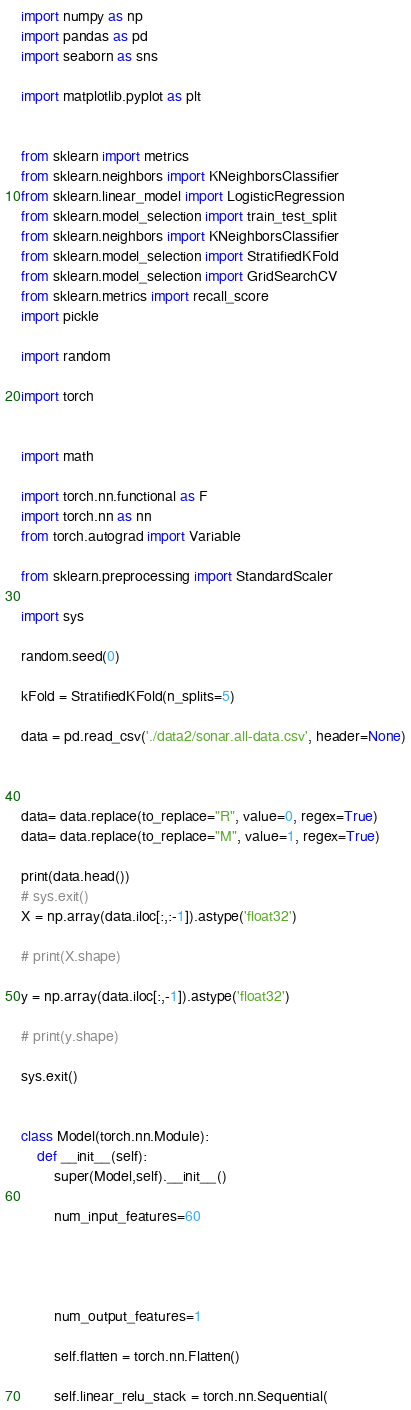Convert code to text. <code><loc_0><loc_0><loc_500><loc_500><_Python_>import numpy as np
import pandas as pd
import seaborn as sns

import matplotlib.pyplot as plt


from sklearn import metrics
from sklearn.neighbors import KNeighborsClassifier
from sklearn.linear_model import LogisticRegression
from sklearn.model_selection import train_test_split
from sklearn.neighbors import KNeighborsClassifier
from sklearn.model_selection import StratifiedKFold
from sklearn.model_selection import GridSearchCV
from sklearn.metrics import recall_score
import pickle

import random

import torch


import math

import torch.nn.functional as F
import torch.nn as nn
from torch.autograd import Variable

from sklearn.preprocessing import StandardScaler

import sys

random.seed(0)

kFold = StratifiedKFold(n_splits=5)

data = pd.read_csv('./data2/sonar.all-data.csv', header=None)



data= data.replace(to_replace="R", value=0, regex=True)
data= data.replace(to_replace="M", value=1, regex=True)

print(data.head())
# sys.exit()
X = np.array(data.iloc[:,:-1]).astype('float32')

# print(X.shape)

y = np.array(data.iloc[:,-1]).astype('float32')

# print(y.shape)

sys.exit()


class Model(torch.nn.Module):
    def __init__(self):
        super(Model,self).__init__()
        
        num_input_features=60

       
       
       
        num_output_features=1

        self.flatten = torch.nn.Flatten()

        self.linear_relu_stack = torch.nn.Sequential(
</code> 